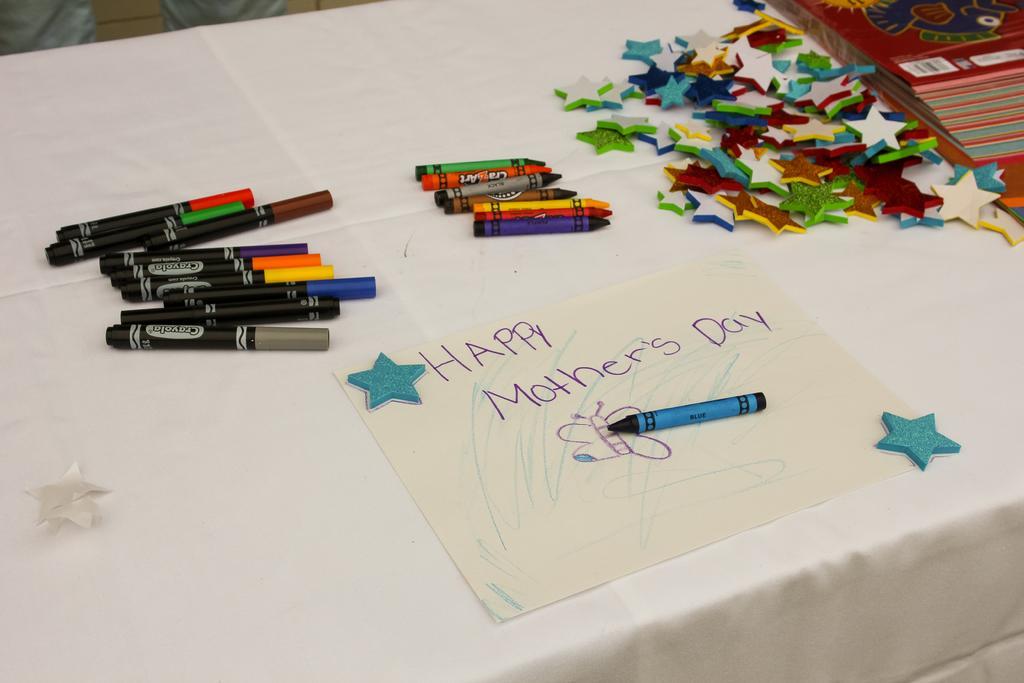How would you summarize this image in a sentence or two? In this image we can see pens, crayons, stars, paper and books placed on the table. 